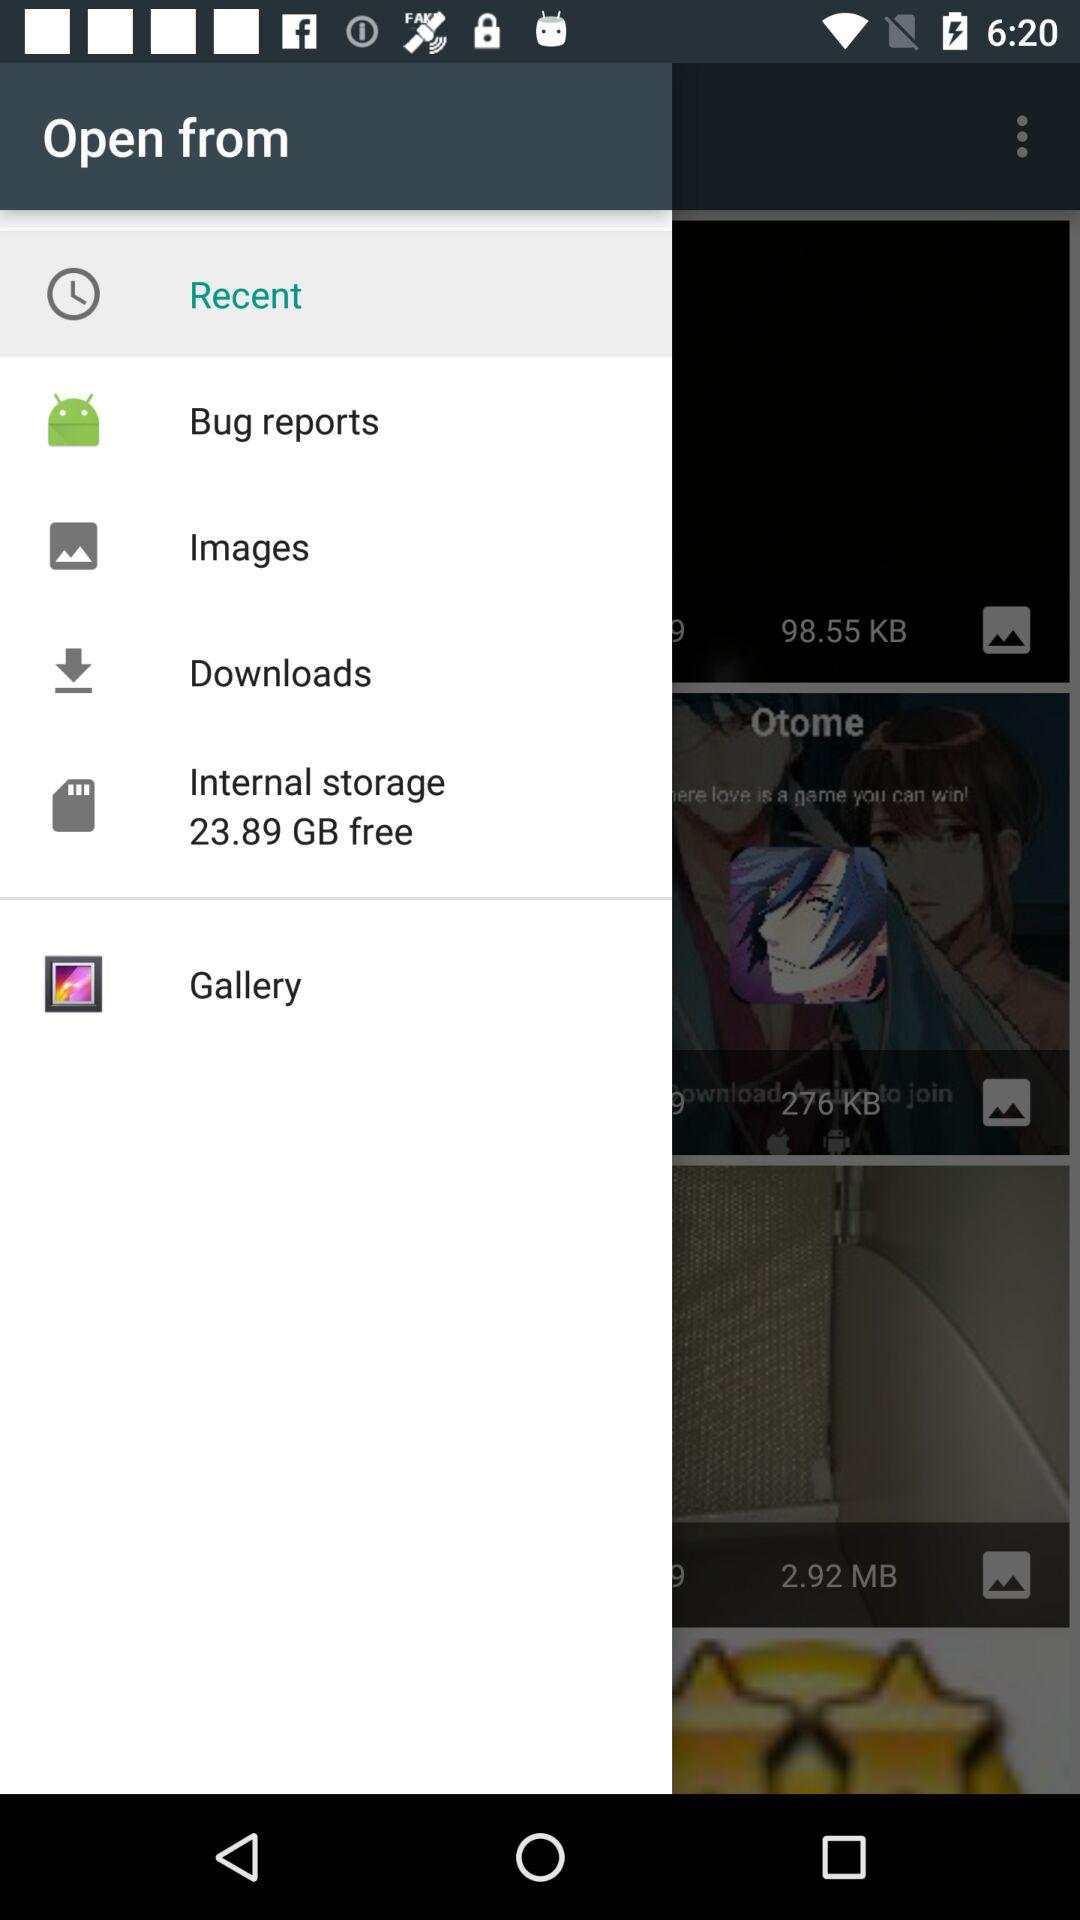What is the size of free internal storage? The size of free internal storage is 23.89 GB. 